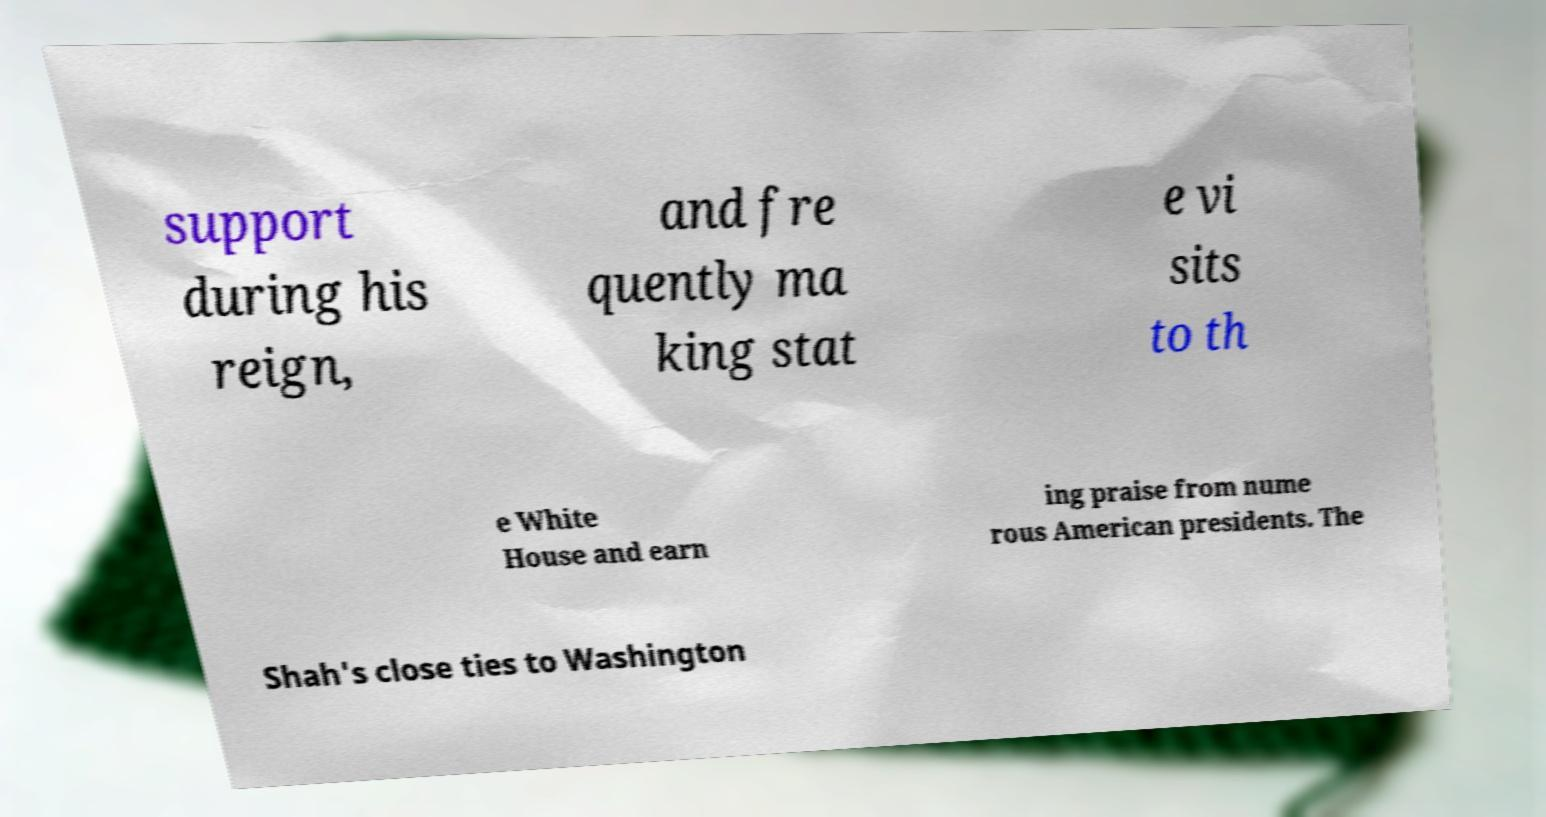Can you read and provide the text displayed in the image?This photo seems to have some interesting text. Can you extract and type it out for me? support during his reign, and fre quently ma king stat e vi sits to th e White House and earn ing praise from nume rous American presidents. The Shah's close ties to Washington 